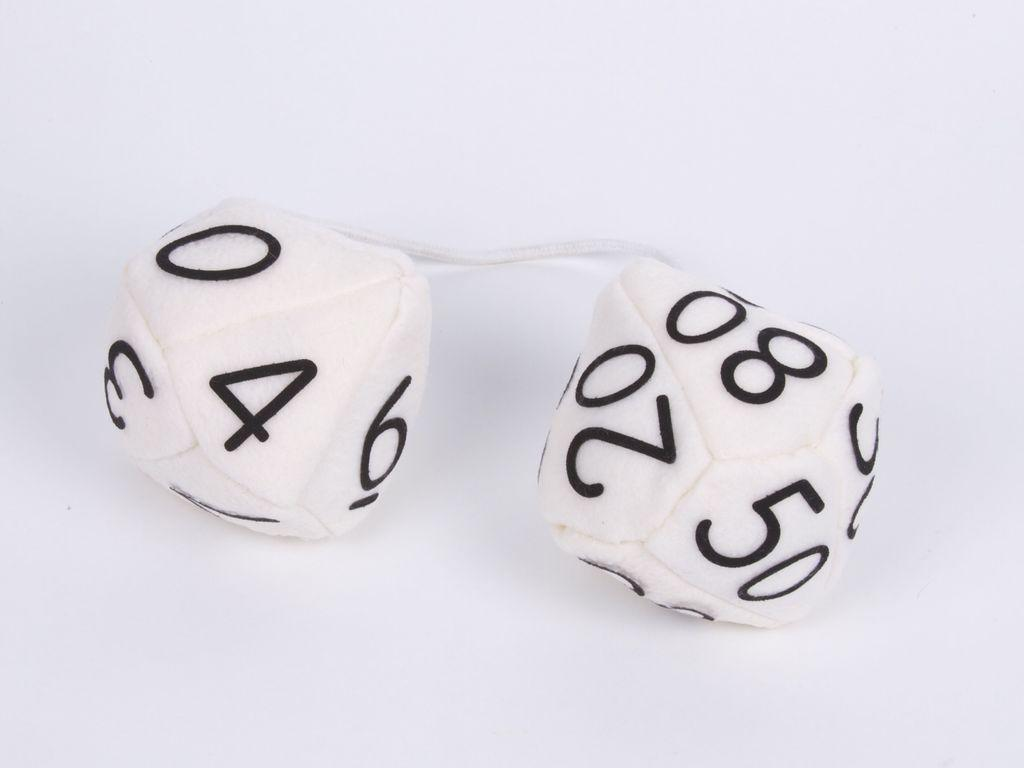What objects are present in the image? There are dice in the image. What is the dice placed on? The dice are on a white platform. What type of brass instrument can be seen in the image? There is no brass instrument present in the image; it only features dice on a white platform. 